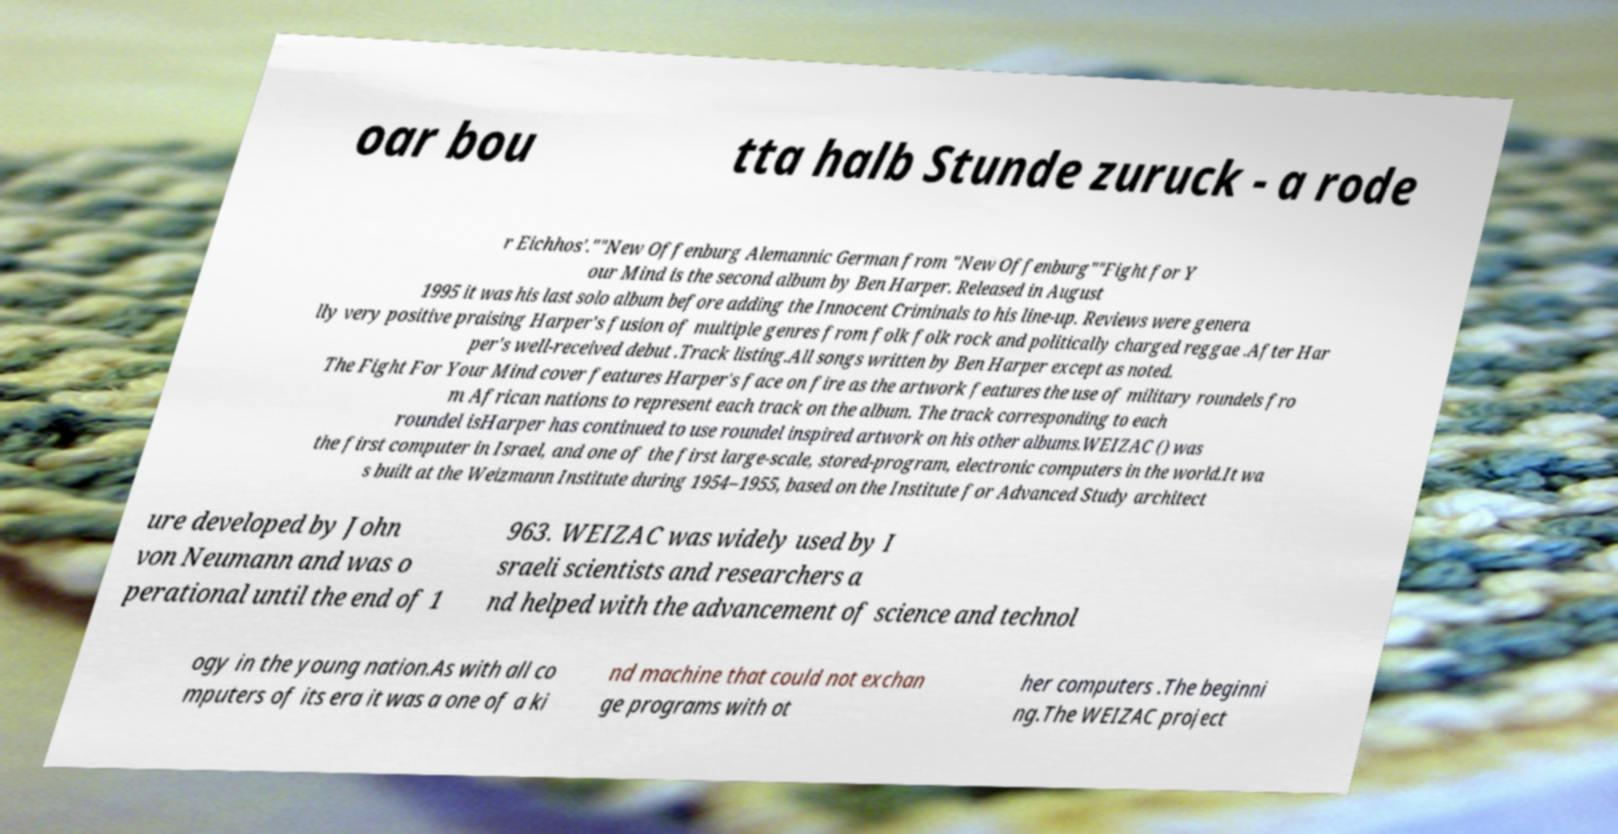Could you extract and type out the text from this image? oar bou tta halb Stunde zuruck - a rode r Eichhos'.""New Offenburg Alemannic German from "New Offenburg""Fight for Y our Mind is the second album by Ben Harper. Released in August 1995 it was his last solo album before adding the Innocent Criminals to his line-up. Reviews were genera lly very positive praising Harper's fusion of multiple genres from folk folk rock and politically charged reggae .After Har per's well-received debut .Track listing.All songs written by Ben Harper except as noted. The Fight For Your Mind cover features Harper's face on fire as the artwork features the use of military roundels fro m African nations to represent each track on the album. The track corresponding to each roundel isHarper has continued to use roundel inspired artwork on his other albums.WEIZAC () was the first computer in Israel, and one of the first large-scale, stored-program, electronic computers in the world.It wa s built at the Weizmann Institute during 1954–1955, based on the Institute for Advanced Study architect ure developed by John von Neumann and was o perational until the end of 1 963. WEIZAC was widely used by I sraeli scientists and researchers a nd helped with the advancement of science and technol ogy in the young nation.As with all co mputers of its era it was a one of a ki nd machine that could not exchan ge programs with ot her computers .The beginni ng.The WEIZAC project 